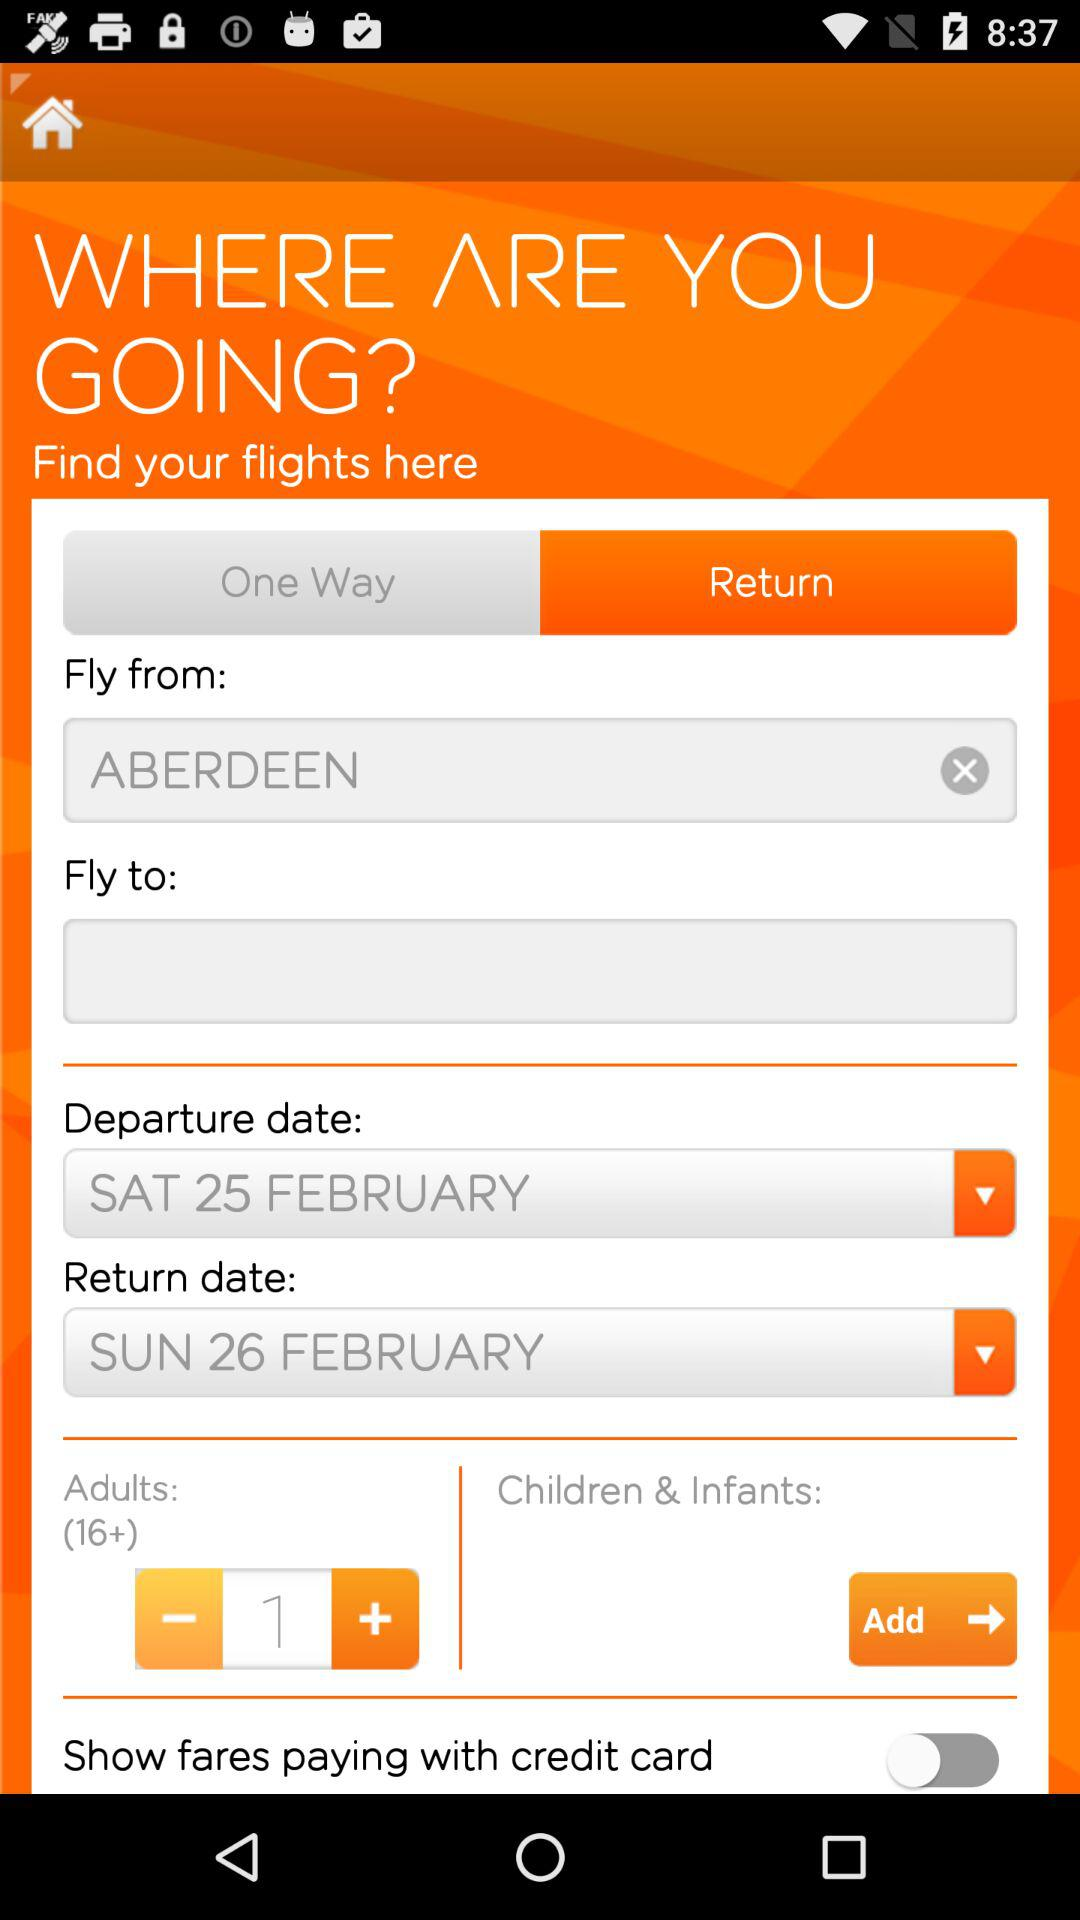Which option is selected, "One Way" or "Return"? The selected option is "Return". 